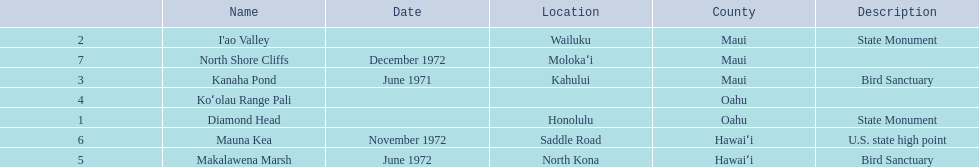How many images are listed? 6. 